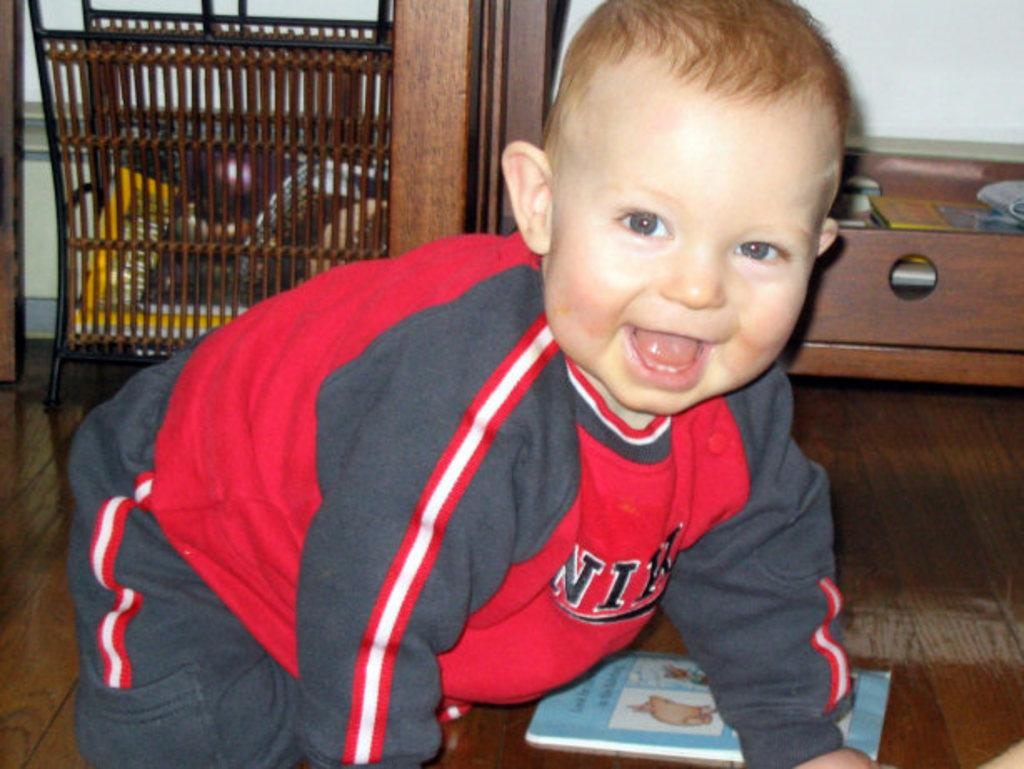<image>
Give a short and clear explanation of the subsequent image. Baby wearing a red and black sweater which says NIKE. 